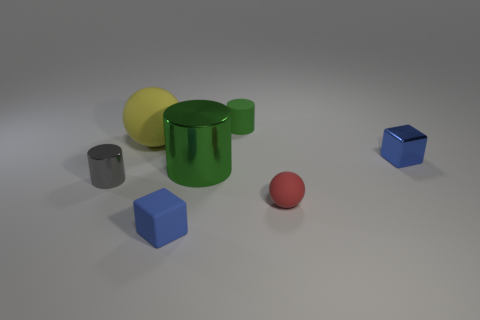Are there fewer blue rubber things behind the gray metallic cylinder than large matte cylinders?
Give a very brief answer. No. Is there a small metal block of the same color as the tiny rubber cylinder?
Ensure brevity in your answer.  No. Is the shape of the tiny green thing the same as the small metallic thing to the right of the big green metal thing?
Make the answer very short. No. Is there a tiny green object that has the same material as the gray object?
Your answer should be very brief. No. Is there a tiny blue object behind the shiny thing that is to the left of the blue block that is in front of the gray thing?
Give a very brief answer. Yes. How many other things are the same shape as the gray object?
Offer a terse response. 2. What color is the large thing on the right side of the cube left of the small blue cube that is to the right of the matte cylinder?
Make the answer very short. Green. How many blue blocks are there?
Your response must be concise. 2. How many big objects are purple cylinders or cylinders?
Ensure brevity in your answer.  1. The blue object that is the same size as the blue metallic block is what shape?
Make the answer very short. Cube. 